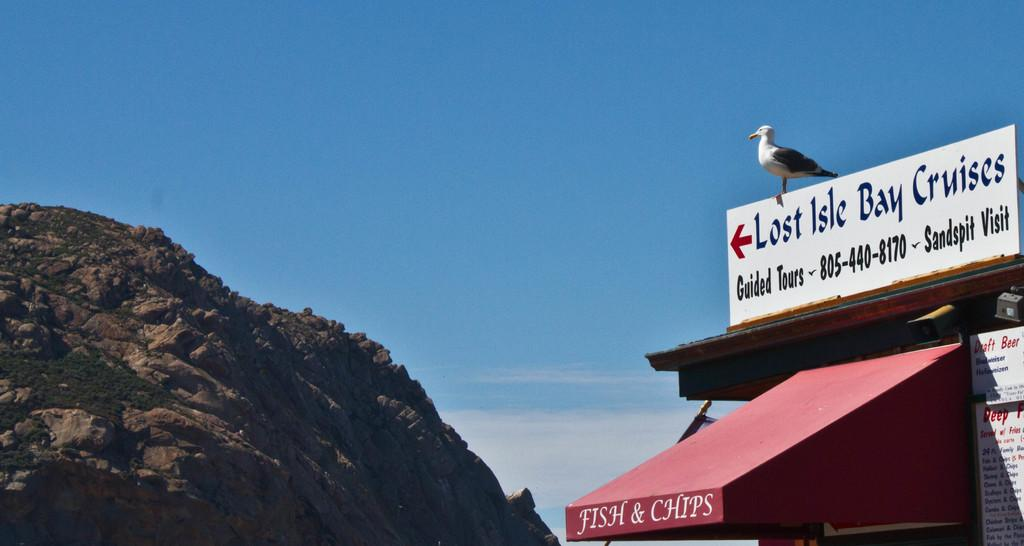<image>
Give a short and clear explanation of the subsequent image. Lost Isle Bay Cruises is to the left of the Fish & Chips. 